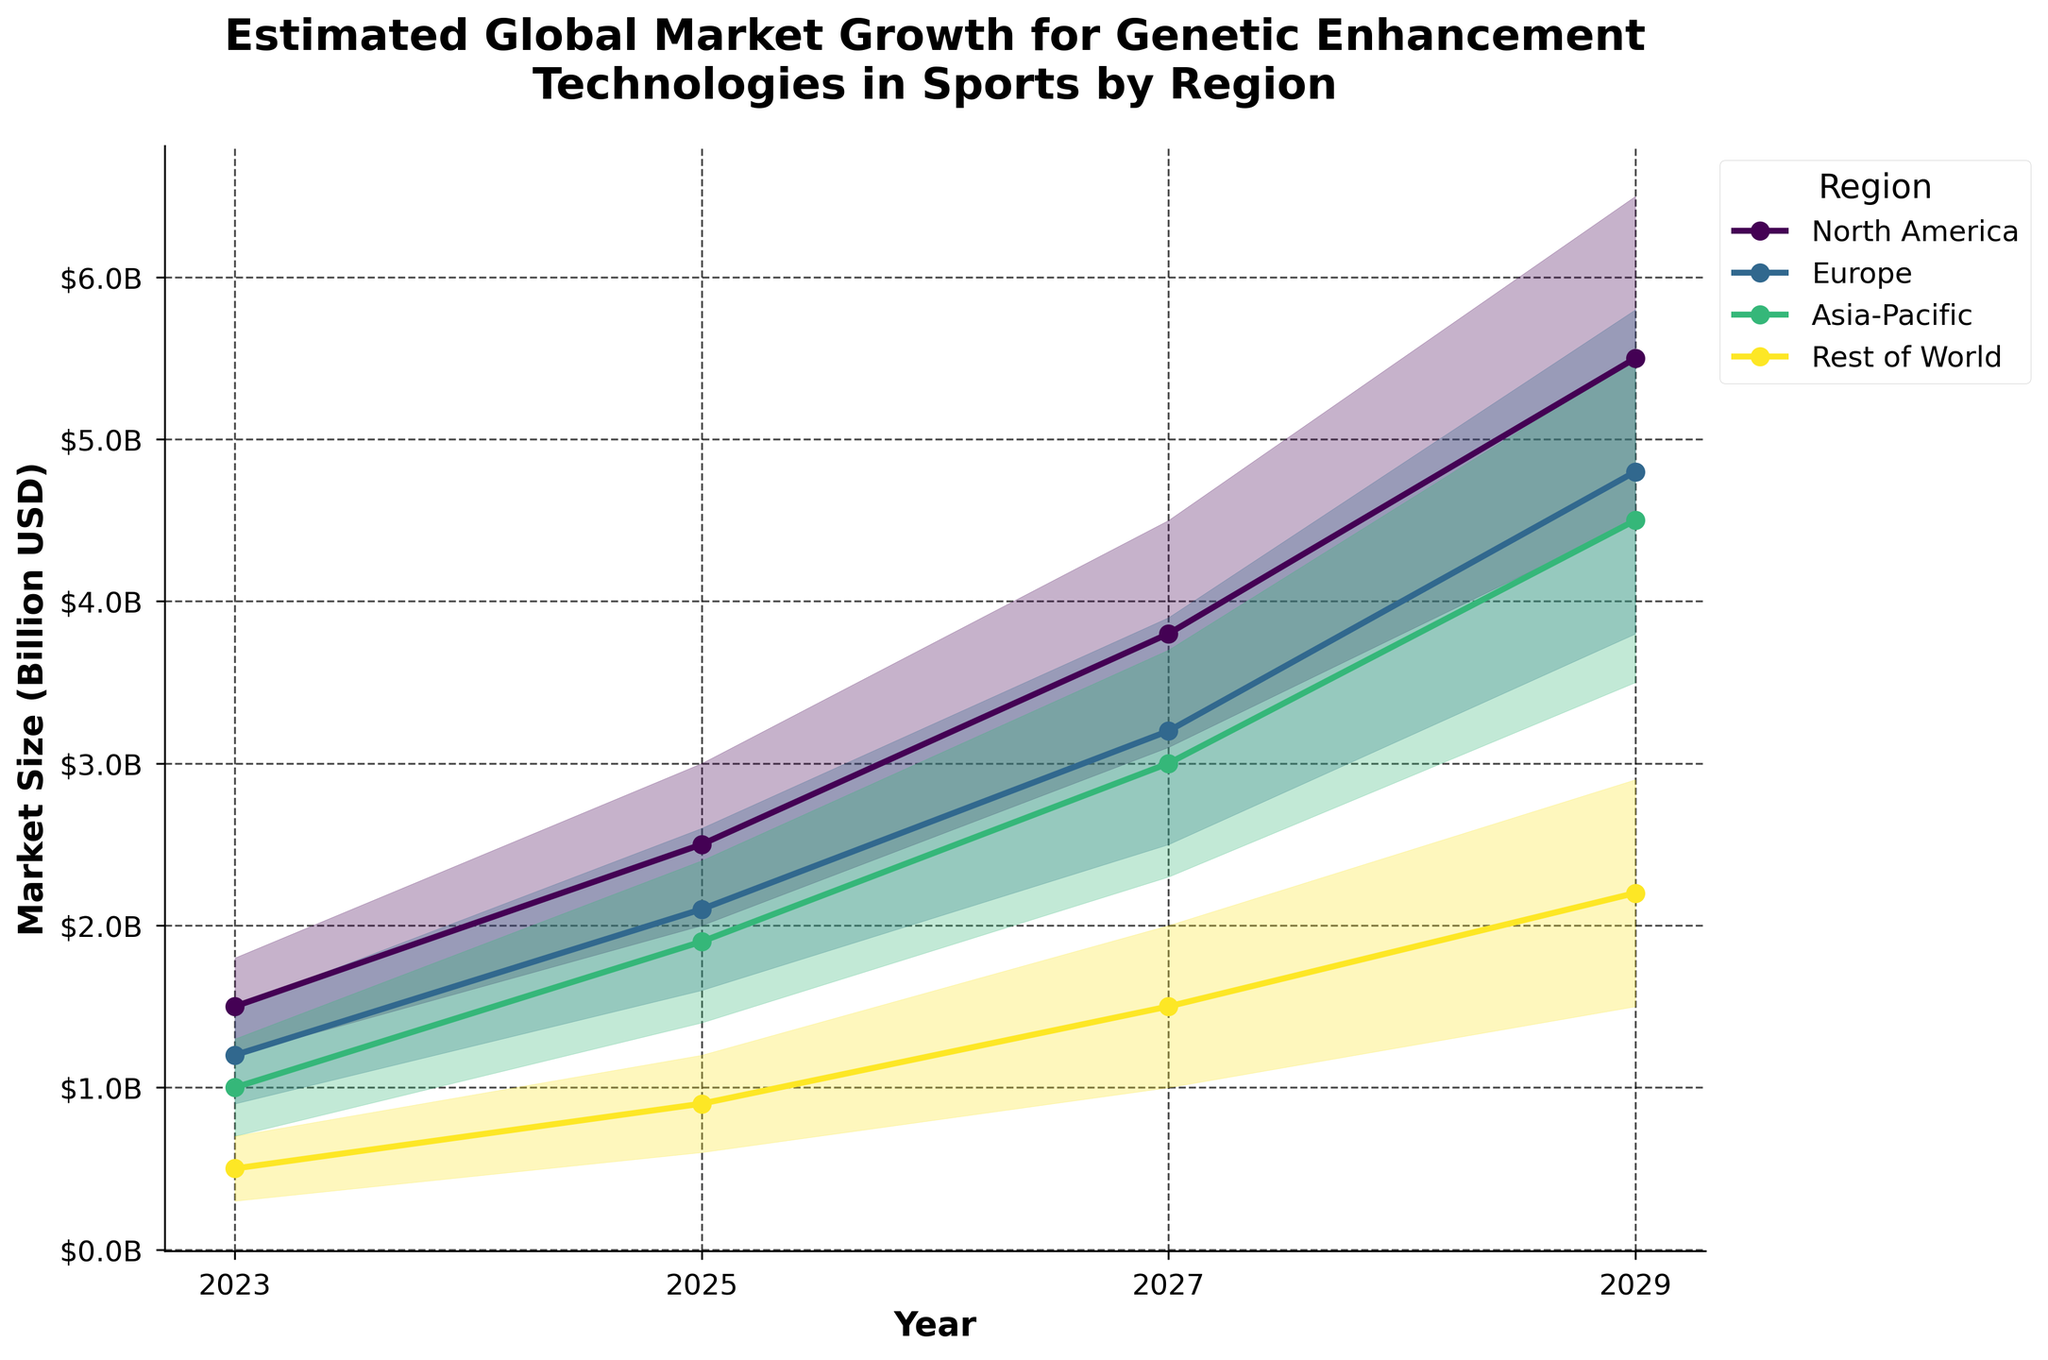What is the title of the chart? The title can be found at the top center of the chart. It reads: "Estimated Global Market Growth for Genetic Enhancement Technologies in Sports by Region".
Answer: Estimated Global Market Growth for Genetic Enhancement Technologies in Sports by Region Which region has the highest medium estimate in 2029? To determine this, look at the year 2029 on the x-axis and find the medium estimate line for each region. The line with the highest value indicates the region.
Answer: North America What is the range of the market size estimates for Europe in 2027? For the year 2027, find the low and high estimates for Europe on the chart. The range is the difference between these two values.
Answer: 2.5 to 3.9 billion USD Which region shows the consistent increase in medium estimate values from 2023 to 2029? Compare the slopes of the medium estimate lines for all regions from 2023 to 2029. The line that consistently increases represents the region.
Answer: All regions show a consistent increase, but North America has the steepest slope By how much does the high estimate for the Asia-Pacific region increase from 2023 to 2029? Subtract the high estimate value for Asia-Pacific in 2023 from the high estimate value for Asia-Pacific in 2029 to find the increase.
Answer: 4.2 billion USD Between 2025 and 2027, which region has the smallest increase in medium estimate? Check the medium estimate values for all regions in 2025 and 2027, and then subtract the 2025 value from the 2027 value for each region. The smallest result indicates the region.
Answer: Rest of World What region had the lowest market size estimate in 2023? Observe the low estimate values for all regions in 2023 and determine which one is the smallest.
Answer: Rest of World Which two regions have the closest medium estimates in 2025? Compare the medium estimates of all regions for the year 2025 and determine which two are closest in value.
Answer: Europe and Asia-Pacific By how much is the medium estimate for North America higher in 2029 compared to 2023? Subtract the medium estimate for North America in 2023 from the medium estimate for North America in 2029.
Answer: 4.0 billion USD 